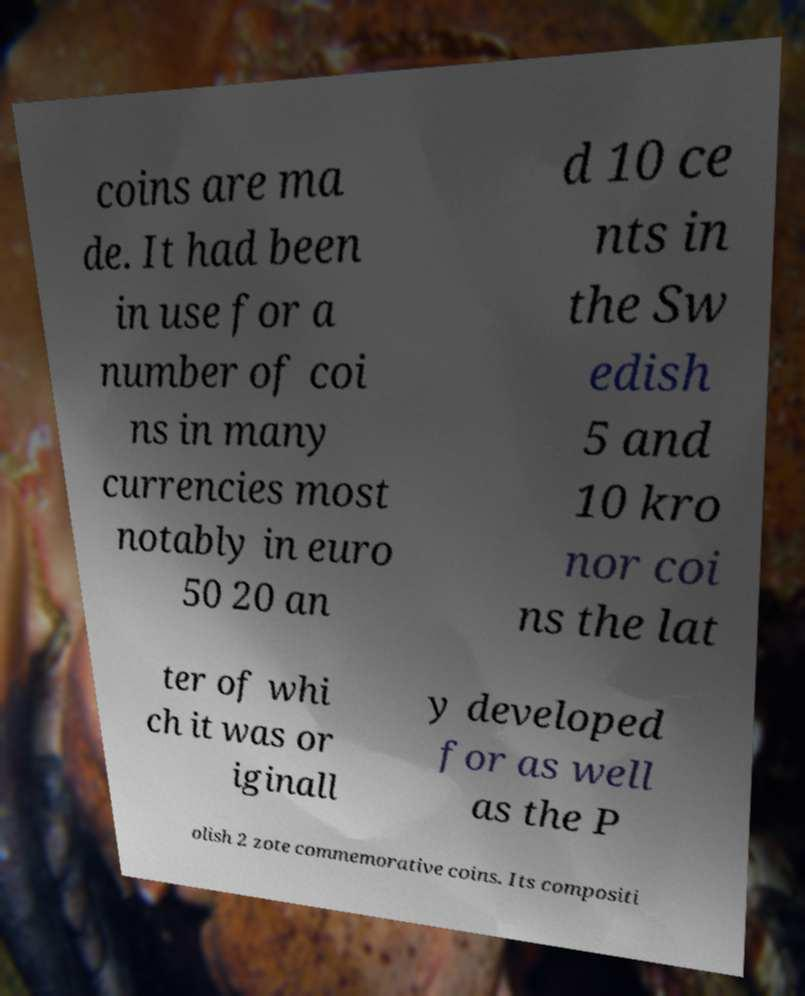Can you accurately transcribe the text from the provided image for me? coins are ma de. It had been in use for a number of coi ns in many currencies most notably in euro 50 20 an d 10 ce nts in the Sw edish 5 and 10 kro nor coi ns the lat ter of whi ch it was or iginall y developed for as well as the P olish 2 zote commemorative coins. Its compositi 